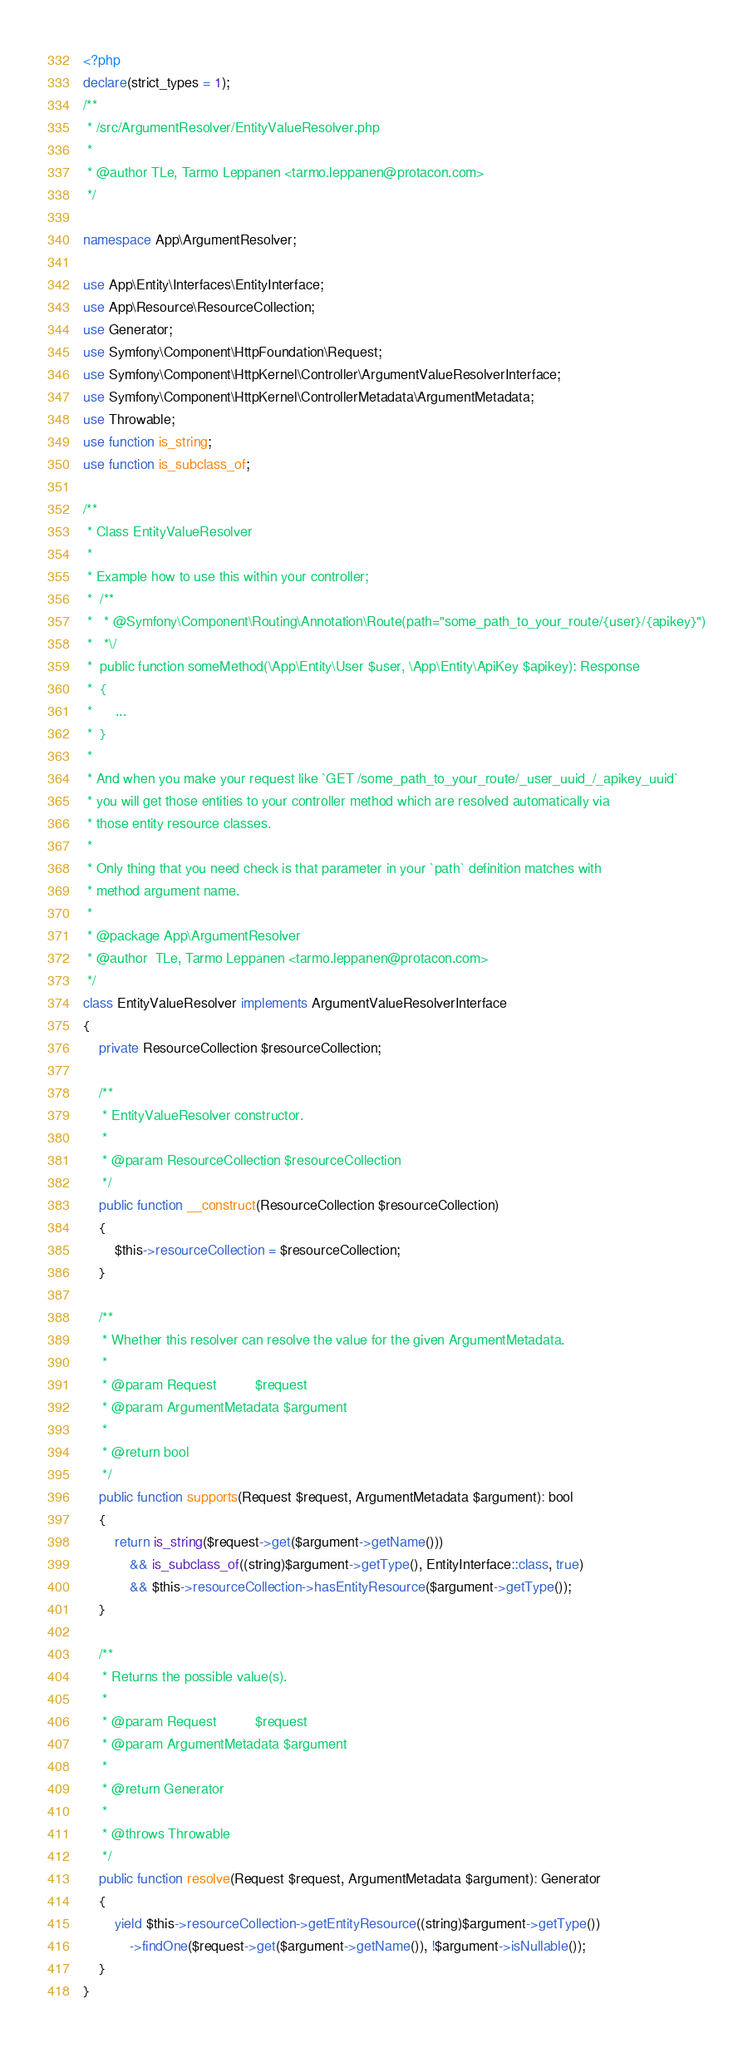Convert code to text. <code><loc_0><loc_0><loc_500><loc_500><_PHP_><?php
declare(strict_types = 1);
/**
 * /src/ArgumentResolver/EntityValueResolver.php
 *
 * @author TLe, Tarmo Leppänen <tarmo.leppanen@protacon.com>
 */

namespace App\ArgumentResolver;

use App\Entity\Interfaces\EntityInterface;
use App\Resource\ResourceCollection;
use Generator;
use Symfony\Component\HttpFoundation\Request;
use Symfony\Component\HttpKernel\Controller\ArgumentValueResolverInterface;
use Symfony\Component\HttpKernel\ControllerMetadata\ArgumentMetadata;
use Throwable;
use function is_string;
use function is_subclass_of;

/**
 * Class EntityValueResolver
 *
 * Example how to use this within your controller;
 *  /**
 *   * @Symfony\Component\Routing\Annotation\Route(path="some_path_to_your_route/{user}/{apikey}")
 *   *\/
 *  public function someMethod(\App\Entity\User $user, \App\Entity\ApiKey $apikey): Response
 *  {
 *      ...
 *  }
 *
 * And when you make your request like `GET /some_path_to_your_route/_user_uuid_/_apikey_uuid`
 * you will get those entities to your controller method which are resolved automatically via
 * those entity resource classes.
 *
 * Only thing that you need check is that parameter in your `path` definition matches with
 * method argument name.
 *
 * @package App\ArgumentResolver
 * @author  TLe, Tarmo Leppänen <tarmo.leppanen@protacon.com>
 */
class EntityValueResolver implements ArgumentValueResolverInterface
{
    private ResourceCollection $resourceCollection;

    /**
     * EntityValueResolver constructor.
     *
     * @param ResourceCollection $resourceCollection
     */
    public function __construct(ResourceCollection $resourceCollection)
    {
        $this->resourceCollection = $resourceCollection;
    }

    /**
     * Whether this resolver can resolve the value for the given ArgumentMetadata.
     *
     * @param Request          $request
     * @param ArgumentMetadata $argument
     *
     * @return bool
     */
    public function supports(Request $request, ArgumentMetadata $argument): bool
    {
        return is_string($request->get($argument->getName()))
            && is_subclass_of((string)$argument->getType(), EntityInterface::class, true)
            && $this->resourceCollection->hasEntityResource($argument->getType());
    }

    /**
     * Returns the possible value(s).
     *
     * @param Request          $request
     * @param ArgumentMetadata $argument
     *
     * @return Generator
     *
     * @throws Throwable
     */
    public function resolve(Request $request, ArgumentMetadata $argument): Generator
    {
        yield $this->resourceCollection->getEntityResource((string)$argument->getType())
            ->findOne($request->get($argument->getName()), !$argument->isNullable());
    }
}
</code> 